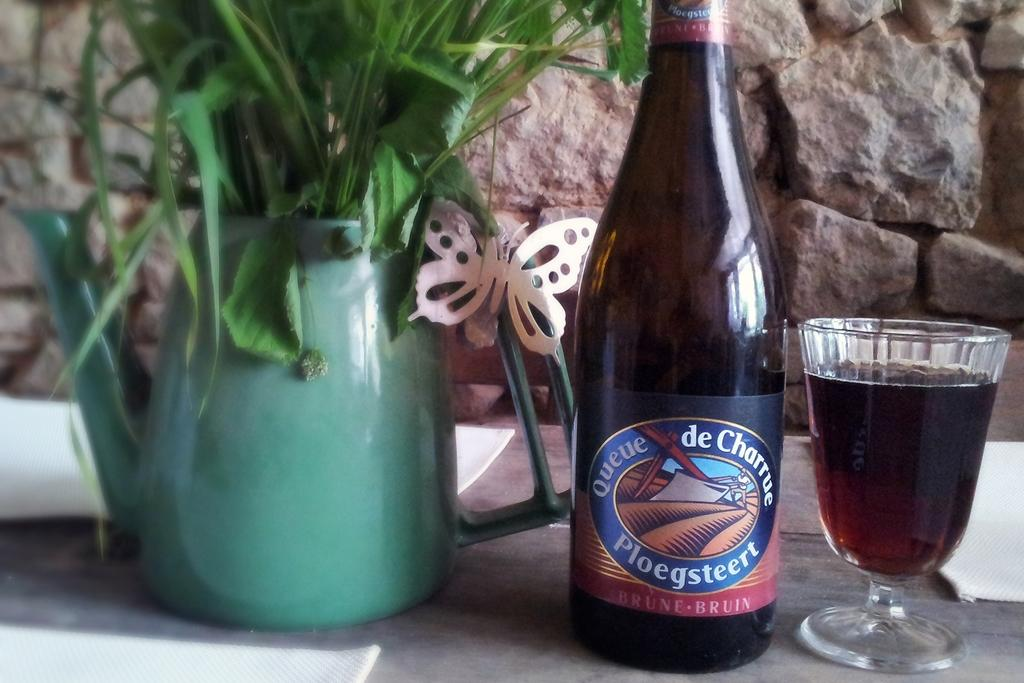<image>
Relay a brief, clear account of the picture shown. A bottle of Queue de Charrue Ploegsteert drink. 